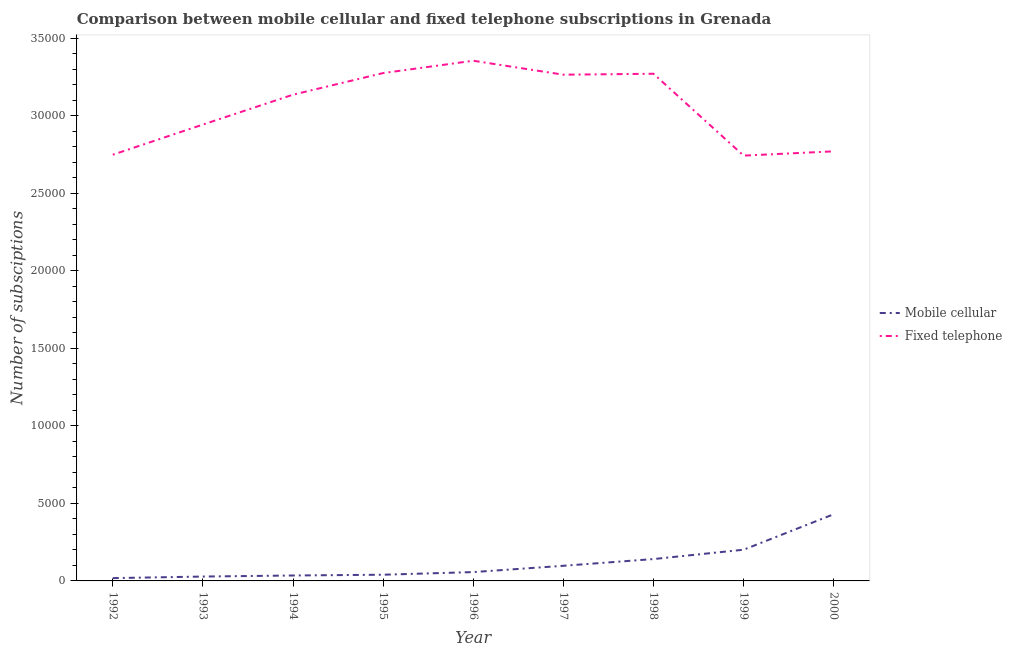Does the line corresponding to number of mobile cellular subscriptions intersect with the line corresponding to number of fixed telephone subscriptions?
Keep it short and to the point. No. Across all years, what is the maximum number of mobile cellular subscriptions?
Your response must be concise. 4300. Across all years, what is the minimum number of mobile cellular subscriptions?
Make the answer very short. 181. What is the total number of mobile cellular subscriptions in the graph?
Offer a very short reply. 1.05e+04. What is the difference between the number of fixed telephone subscriptions in 1997 and that in 1999?
Your answer should be very brief. 5218. What is the difference between the number of fixed telephone subscriptions in 1992 and the number of mobile cellular subscriptions in 1995?
Keep it short and to the point. 2.71e+04. What is the average number of fixed telephone subscriptions per year?
Ensure brevity in your answer.  3.06e+04. In the year 1996, what is the difference between the number of fixed telephone subscriptions and number of mobile cellular subscriptions?
Give a very brief answer. 3.30e+04. What is the ratio of the number of mobile cellular subscriptions in 1993 to that in 1996?
Offer a terse response. 0.49. Is the number of mobile cellular subscriptions in 1995 less than that in 2000?
Your answer should be compact. Yes. What is the difference between the highest and the second highest number of mobile cellular subscriptions?
Keep it short and to the point. 2288. What is the difference between the highest and the lowest number of mobile cellular subscriptions?
Provide a short and direct response. 4119. Does the number of mobile cellular subscriptions monotonically increase over the years?
Your answer should be very brief. Yes. Is the number of mobile cellular subscriptions strictly less than the number of fixed telephone subscriptions over the years?
Keep it short and to the point. Yes. Does the graph contain grids?
Offer a very short reply. No. What is the title of the graph?
Give a very brief answer. Comparison between mobile cellular and fixed telephone subscriptions in Grenada. Does "Formally registered" appear as one of the legend labels in the graph?
Keep it short and to the point. No. What is the label or title of the X-axis?
Keep it short and to the point. Year. What is the label or title of the Y-axis?
Your response must be concise. Number of subsciptions. What is the Number of subsciptions of Mobile cellular in 1992?
Offer a terse response. 181. What is the Number of subsciptions in Fixed telephone in 1992?
Offer a very short reply. 2.75e+04. What is the Number of subsciptions in Mobile cellular in 1993?
Offer a terse response. 282. What is the Number of subsciptions in Fixed telephone in 1993?
Make the answer very short. 2.94e+04. What is the Number of subsciptions of Mobile cellular in 1994?
Give a very brief answer. 350. What is the Number of subsciptions in Fixed telephone in 1994?
Make the answer very short. 3.14e+04. What is the Number of subsciptions in Fixed telephone in 1995?
Provide a succinct answer. 3.28e+04. What is the Number of subsciptions of Mobile cellular in 1996?
Provide a short and direct response. 570. What is the Number of subsciptions of Fixed telephone in 1996?
Your response must be concise. 3.35e+04. What is the Number of subsciptions of Mobile cellular in 1997?
Your answer should be compact. 976. What is the Number of subsciptions in Fixed telephone in 1997?
Ensure brevity in your answer.  3.26e+04. What is the Number of subsciptions in Mobile cellular in 1998?
Give a very brief answer. 1410. What is the Number of subsciptions of Fixed telephone in 1998?
Ensure brevity in your answer.  3.27e+04. What is the Number of subsciptions in Mobile cellular in 1999?
Offer a very short reply. 2012. What is the Number of subsciptions of Fixed telephone in 1999?
Make the answer very short. 2.74e+04. What is the Number of subsciptions of Mobile cellular in 2000?
Provide a succinct answer. 4300. What is the Number of subsciptions of Fixed telephone in 2000?
Keep it short and to the point. 2.77e+04. Across all years, what is the maximum Number of subsciptions of Mobile cellular?
Offer a very short reply. 4300. Across all years, what is the maximum Number of subsciptions in Fixed telephone?
Your answer should be very brief. 3.35e+04. Across all years, what is the minimum Number of subsciptions in Mobile cellular?
Make the answer very short. 181. Across all years, what is the minimum Number of subsciptions of Fixed telephone?
Make the answer very short. 2.74e+04. What is the total Number of subsciptions in Mobile cellular in the graph?
Provide a short and direct response. 1.05e+04. What is the total Number of subsciptions in Fixed telephone in the graph?
Provide a short and direct response. 2.75e+05. What is the difference between the Number of subsciptions of Mobile cellular in 1992 and that in 1993?
Ensure brevity in your answer.  -101. What is the difference between the Number of subsciptions of Fixed telephone in 1992 and that in 1993?
Offer a terse response. -1945. What is the difference between the Number of subsciptions in Mobile cellular in 1992 and that in 1994?
Offer a terse response. -169. What is the difference between the Number of subsciptions in Fixed telephone in 1992 and that in 1994?
Ensure brevity in your answer.  -3871. What is the difference between the Number of subsciptions of Mobile cellular in 1992 and that in 1995?
Your answer should be compact. -219. What is the difference between the Number of subsciptions in Fixed telephone in 1992 and that in 1995?
Your response must be concise. -5266. What is the difference between the Number of subsciptions in Mobile cellular in 1992 and that in 1996?
Your answer should be very brief. -389. What is the difference between the Number of subsciptions of Fixed telephone in 1992 and that in 1996?
Your response must be concise. -6060. What is the difference between the Number of subsciptions in Mobile cellular in 1992 and that in 1997?
Your answer should be very brief. -795. What is the difference between the Number of subsciptions in Fixed telephone in 1992 and that in 1997?
Offer a terse response. -5160. What is the difference between the Number of subsciptions of Mobile cellular in 1992 and that in 1998?
Keep it short and to the point. -1229. What is the difference between the Number of subsciptions in Fixed telephone in 1992 and that in 1998?
Your answer should be compact. -5221. What is the difference between the Number of subsciptions in Mobile cellular in 1992 and that in 1999?
Offer a terse response. -1831. What is the difference between the Number of subsciptions in Fixed telephone in 1992 and that in 1999?
Provide a succinct answer. 58. What is the difference between the Number of subsciptions in Mobile cellular in 1992 and that in 2000?
Your answer should be compact. -4119. What is the difference between the Number of subsciptions of Fixed telephone in 1992 and that in 2000?
Keep it short and to the point. -218. What is the difference between the Number of subsciptions in Mobile cellular in 1993 and that in 1994?
Keep it short and to the point. -68. What is the difference between the Number of subsciptions of Fixed telephone in 1993 and that in 1994?
Your response must be concise. -1926. What is the difference between the Number of subsciptions of Mobile cellular in 1993 and that in 1995?
Offer a very short reply. -118. What is the difference between the Number of subsciptions of Fixed telephone in 1993 and that in 1995?
Make the answer very short. -3321. What is the difference between the Number of subsciptions in Mobile cellular in 1993 and that in 1996?
Provide a succinct answer. -288. What is the difference between the Number of subsciptions of Fixed telephone in 1993 and that in 1996?
Your answer should be compact. -4115. What is the difference between the Number of subsciptions of Mobile cellular in 1993 and that in 1997?
Keep it short and to the point. -694. What is the difference between the Number of subsciptions in Fixed telephone in 1993 and that in 1997?
Your response must be concise. -3215. What is the difference between the Number of subsciptions in Mobile cellular in 1993 and that in 1998?
Your response must be concise. -1128. What is the difference between the Number of subsciptions in Fixed telephone in 1993 and that in 1998?
Offer a terse response. -3276. What is the difference between the Number of subsciptions of Mobile cellular in 1993 and that in 1999?
Provide a short and direct response. -1730. What is the difference between the Number of subsciptions of Fixed telephone in 1993 and that in 1999?
Offer a terse response. 2003. What is the difference between the Number of subsciptions of Mobile cellular in 1993 and that in 2000?
Give a very brief answer. -4018. What is the difference between the Number of subsciptions of Fixed telephone in 1993 and that in 2000?
Keep it short and to the point. 1727. What is the difference between the Number of subsciptions in Mobile cellular in 1994 and that in 1995?
Your answer should be very brief. -50. What is the difference between the Number of subsciptions in Fixed telephone in 1994 and that in 1995?
Provide a succinct answer. -1395. What is the difference between the Number of subsciptions of Mobile cellular in 1994 and that in 1996?
Your answer should be very brief. -220. What is the difference between the Number of subsciptions of Fixed telephone in 1994 and that in 1996?
Provide a short and direct response. -2189. What is the difference between the Number of subsciptions in Mobile cellular in 1994 and that in 1997?
Ensure brevity in your answer.  -626. What is the difference between the Number of subsciptions of Fixed telephone in 1994 and that in 1997?
Ensure brevity in your answer.  -1289. What is the difference between the Number of subsciptions in Mobile cellular in 1994 and that in 1998?
Offer a very short reply. -1060. What is the difference between the Number of subsciptions of Fixed telephone in 1994 and that in 1998?
Offer a very short reply. -1350. What is the difference between the Number of subsciptions in Mobile cellular in 1994 and that in 1999?
Your response must be concise. -1662. What is the difference between the Number of subsciptions in Fixed telephone in 1994 and that in 1999?
Offer a very short reply. 3929. What is the difference between the Number of subsciptions in Mobile cellular in 1994 and that in 2000?
Give a very brief answer. -3950. What is the difference between the Number of subsciptions of Fixed telephone in 1994 and that in 2000?
Your answer should be very brief. 3653. What is the difference between the Number of subsciptions of Mobile cellular in 1995 and that in 1996?
Offer a very short reply. -170. What is the difference between the Number of subsciptions of Fixed telephone in 1995 and that in 1996?
Offer a very short reply. -794. What is the difference between the Number of subsciptions of Mobile cellular in 1995 and that in 1997?
Provide a succinct answer. -576. What is the difference between the Number of subsciptions of Fixed telephone in 1995 and that in 1997?
Ensure brevity in your answer.  106. What is the difference between the Number of subsciptions in Mobile cellular in 1995 and that in 1998?
Provide a succinct answer. -1010. What is the difference between the Number of subsciptions in Mobile cellular in 1995 and that in 1999?
Provide a short and direct response. -1612. What is the difference between the Number of subsciptions of Fixed telephone in 1995 and that in 1999?
Ensure brevity in your answer.  5324. What is the difference between the Number of subsciptions in Mobile cellular in 1995 and that in 2000?
Provide a succinct answer. -3900. What is the difference between the Number of subsciptions of Fixed telephone in 1995 and that in 2000?
Make the answer very short. 5048. What is the difference between the Number of subsciptions of Mobile cellular in 1996 and that in 1997?
Offer a very short reply. -406. What is the difference between the Number of subsciptions of Fixed telephone in 1996 and that in 1997?
Provide a short and direct response. 900. What is the difference between the Number of subsciptions of Mobile cellular in 1996 and that in 1998?
Ensure brevity in your answer.  -840. What is the difference between the Number of subsciptions in Fixed telephone in 1996 and that in 1998?
Your response must be concise. 839. What is the difference between the Number of subsciptions in Mobile cellular in 1996 and that in 1999?
Offer a very short reply. -1442. What is the difference between the Number of subsciptions of Fixed telephone in 1996 and that in 1999?
Your response must be concise. 6118. What is the difference between the Number of subsciptions of Mobile cellular in 1996 and that in 2000?
Provide a short and direct response. -3730. What is the difference between the Number of subsciptions of Fixed telephone in 1996 and that in 2000?
Your answer should be compact. 5842. What is the difference between the Number of subsciptions of Mobile cellular in 1997 and that in 1998?
Ensure brevity in your answer.  -434. What is the difference between the Number of subsciptions in Fixed telephone in 1997 and that in 1998?
Make the answer very short. -61. What is the difference between the Number of subsciptions of Mobile cellular in 1997 and that in 1999?
Your answer should be very brief. -1036. What is the difference between the Number of subsciptions in Fixed telephone in 1997 and that in 1999?
Your answer should be compact. 5218. What is the difference between the Number of subsciptions in Mobile cellular in 1997 and that in 2000?
Offer a very short reply. -3324. What is the difference between the Number of subsciptions in Fixed telephone in 1997 and that in 2000?
Your response must be concise. 4942. What is the difference between the Number of subsciptions in Mobile cellular in 1998 and that in 1999?
Offer a very short reply. -602. What is the difference between the Number of subsciptions in Fixed telephone in 1998 and that in 1999?
Your answer should be compact. 5279. What is the difference between the Number of subsciptions of Mobile cellular in 1998 and that in 2000?
Your answer should be very brief. -2890. What is the difference between the Number of subsciptions of Fixed telephone in 1998 and that in 2000?
Provide a succinct answer. 5003. What is the difference between the Number of subsciptions of Mobile cellular in 1999 and that in 2000?
Your answer should be compact. -2288. What is the difference between the Number of subsciptions of Fixed telephone in 1999 and that in 2000?
Provide a short and direct response. -276. What is the difference between the Number of subsciptions in Mobile cellular in 1992 and the Number of subsciptions in Fixed telephone in 1993?
Offer a terse response. -2.92e+04. What is the difference between the Number of subsciptions in Mobile cellular in 1992 and the Number of subsciptions in Fixed telephone in 1994?
Give a very brief answer. -3.12e+04. What is the difference between the Number of subsciptions of Mobile cellular in 1992 and the Number of subsciptions of Fixed telephone in 1995?
Provide a short and direct response. -3.26e+04. What is the difference between the Number of subsciptions in Mobile cellular in 1992 and the Number of subsciptions in Fixed telephone in 1996?
Offer a very short reply. -3.34e+04. What is the difference between the Number of subsciptions in Mobile cellular in 1992 and the Number of subsciptions in Fixed telephone in 1997?
Offer a very short reply. -3.25e+04. What is the difference between the Number of subsciptions in Mobile cellular in 1992 and the Number of subsciptions in Fixed telephone in 1998?
Offer a very short reply. -3.25e+04. What is the difference between the Number of subsciptions of Mobile cellular in 1992 and the Number of subsciptions of Fixed telephone in 1999?
Ensure brevity in your answer.  -2.72e+04. What is the difference between the Number of subsciptions of Mobile cellular in 1992 and the Number of subsciptions of Fixed telephone in 2000?
Offer a terse response. -2.75e+04. What is the difference between the Number of subsciptions in Mobile cellular in 1993 and the Number of subsciptions in Fixed telephone in 1994?
Your answer should be very brief. -3.11e+04. What is the difference between the Number of subsciptions in Mobile cellular in 1993 and the Number of subsciptions in Fixed telephone in 1995?
Offer a very short reply. -3.25e+04. What is the difference between the Number of subsciptions of Mobile cellular in 1993 and the Number of subsciptions of Fixed telephone in 1996?
Offer a terse response. -3.33e+04. What is the difference between the Number of subsciptions of Mobile cellular in 1993 and the Number of subsciptions of Fixed telephone in 1997?
Offer a terse response. -3.24e+04. What is the difference between the Number of subsciptions of Mobile cellular in 1993 and the Number of subsciptions of Fixed telephone in 1998?
Provide a short and direct response. -3.24e+04. What is the difference between the Number of subsciptions in Mobile cellular in 1993 and the Number of subsciptions in Fixed telephone in 1999?
Ensure brevity in your answer.  -2.71e+04. What is the difference between the Number of subsciptions in Mobile cellular in 1993 and the Number of subsciptions in Fixed telephone in 2000?
Keep it short and to the point. -2.74e+04. What is the difference between the Number of subsciptions in Mobile cellular in 1994 and the Number of subsciptions in Fixed telephone in 1995?
Offer a terse response. -3.24e+04. What is the difference between the Number of subsciptions of Mobile cellular in 1994 and the Number of subsciptions of Fixed telephone in 1996?
Give a very brief answer. -3.32e+04. What is the difference between the Number of subsciptions of Mobile cellular in 1994 and the Number of subsciptions of Fixed telephone in 1997?
Provide a short and direct response. -3.23e+04. What is the difference between the Number of subsciptions in Mobile cellular in 1994 and the Number of subsciptions in Fixed telephone in 1998?
Your answer should be compact. -3.24e+04. What is the difference between the Number of subsciptions in Mobile cellular in 1994 and the Number of subsciptions in Fixed telephone in 1999?
Give a very brief answer. -2.71e+04. What is the difference between the Number of subsciptions in Mobile cellular in 1994 and the Number of subsciptions in Fixed telephone in 2000?
Your answer should be very brief. -2.74e+04. What is the difference between the Number of subsciptions of Mobile cellular in 1995 and the Number of subsciptions of Fixed telephone in 1996?
Your answer should be compact. -3.31e+04. What is the difference between the Number of subsciptions of Mobile cellular in 1995 and the Number of subsciptions of Fixed telephone in 1997?
Provide a short and direct response. -3.22e+04. What is the difference between the Number of subsciptions of Mobile cellular in 1995 and the Number of subsciptions of Fixed telephone in 1998?
Your answer should be very brief. -3.23e+04. What is the difference between the Number of subsciptions in Mobile cellular in 1995 and the Number of subsciptions in Fixed telephone in 1999?
Your response must be concise. -2.70e+04. What is the difference between the Number of subsciptions in Mobile cellular in 1995 and the Number of subsciptions in Fixed telephone in 2000?
Provide a succinct answer. -2.73e+04. What is the difference between the Number of subsciptions in Mobile cellular in 1996 and the Number of subsciptions in Fixed telephone in 1997?
Provide a short and direct response. -3.21e+04. What is the difference between the Number of subsciptions of Mobile cellular in 1996 and the Number of subsciptions of Fixed telephone in 1998?
Ensure brevity in your answer.  -3.21e+04. What is the difference between the Number of subsciptions in Mobile cellular in 1996 and the Number of subsciptions in Fixed telephone in 1999?
Offer a terse response. -2.69e+04. What is the difference between the Number of subsciptions in Mobile cellular in 1996 and the Number of subsciptions in Fixed telephone in 2000?
Provide a short and direct response. -2.71e+04. What is the difference between the Number of subsciptions in Mobile cellular in 1997 and the Number of subsciptions in Fixed telephone in 1998?
Ensure brevity in your answer.  -3.17e+04. What is the difference between the Number of subsciptions in Mobile cellular in 1997 and the Number of subsciptions in Fixed telephone in 1999?
Provide a succinct answer. -2.64e+04. What is the difference between the Number of subsciptions in Mobile cellular in 1997 and the Number of subsciptions in Fixed telephone in 2000?
Make the answer very short. -2.67e+04. What is the difference between the Number of subsciptions of Mobile cellular in 1998 and the Number of subsciptions of Fixed telephone in 1999?
Offer a very short reply. -2.60e+04. What is the difference between the Number of subsciptions of Mobile cellular in 1998 and the Number of subsciptions of Fixed telephone in 2000?
Provide a short and direct response. -2.63e+04. What is the difference between the Number of subsciptions of Mobile cellular in 1999 and the Number of subsciptions of Fixed telephone in 2000?
Provide a short and direct response. -2.57e+04. What is the average Number of subsciptions of Mobile cellular per year?
Offer a very short reply. 1164.56. What is the average Number of subsciptions of Fixed telephone per year?
Your response must be concise. 3.06e+04. In the year 1992, what is the difference between the Number of subsciptions in Mobile cellular and Number of subsciptions in Fixed telephone?
Offer a terse response. -2.73e+04. In the year 1993, what is the difference between the Number of subsciptions of Mobile cellular and Number of subsciptions of Fixed telephone?
Provide a short and direct response. -2.91e+04. In the year 1994, what is the difference between the Number of subsciptions of Mobile cellular and Number of subsciptions of Fixed telephone?
Your answer should be very brief. -3.10e+04. In the year 1995, what is the difference between the Number of subsciptions of Mobile cellular and Number of subsciptions of Fixed telephone?
Offer a very short reply. -3.24e+04. In the year 1996, what is the difference between the Number of subsciptions of Mobile cellular and Number of subsciptions of Fixed telephone?
Give a very brief answer. -3.30e+04. In the year 1997, what is the difference between the Number of subsciptions in Mobile cellular and Number of subsciptions in Fixed telephone?
Give a very brief answer. -3.17e+04. In the year 1998, what is the difference between the Number of subsciptions in Mobile cellular and Number of subsciptions in Fixed telephone?
Give a very brief answer. -3.13e+04. In the year 1999, what is the difference between the Number of subsciptions of Mobile cellular and Number of subsciptions of Fixed telephone?
Make the answer very short. -2.54e+04. In the year 2000, what is the difference between the Number of subsciptions in Mobile cellular and Number of subsciptions in Fixed telephone?
Keep it short and to the point. -2.34e+04. What is the ratio of the Number of subsciptions in Mobile cellular in 1992 to that in 1993?
Give a very brief answer. 0.64. What is the ratio of the Number of subsciptions of Fixed telephone in 1992 to that in 1993?
Your answer should be very brief. 0.93. What is the ratio of the Number of subsciptions in Mobile cellular in 1992 to that in 1994?
Keep it short and to the point. 0.52. What is the ratio of the Number of subsciptions of Fixed telephone in 1992 to that in 1994?
Your response must be concise. 0.88. What is the ratio of the Number of subsciptions of Mobile cellular in 1992 to that in 1995?
Your answer should be compact. 0.45. What is the ratio of the Number of subsciptions in Fixed telephone in 1992 to that in 1995?
Keep it short and to the point. 0.84. What is the ratio of the Number of subsciptions of Mobile cellular in 1992 to that in 1996?
Your answer should be compact. 0.32. What is the ratio of the Number of subsciptions in Fixed telephone in 1992 to that in 1996?
Ensure brevity in your answer.  0.82. What is the ratio of the Number of subsciptions of Mobile cellular in 1992 to that in 1997?
Offer a very short reply. 0.19. What is the ratio of the Number of subsciptions in Fixed telephone in 1992 to that in 1997?
Offer a very short reply. 0.84. What is the ratio of the Number of subsciptions in Mobile cellular in 1992 to that in 1998?
Ensure brevity in your answer.  0.13. What is the ratio of the Number of subsciptions of Fixed telephone in 1992 to that in 1998?
Your answer should be very brief. 0.84. What is the ratio of the Number of subsciptions of Mobile cellular in 1992 to that in 1999?
Your answer should be compact. 0.09. What is the ratio of the Number of subsciptions in Fixed telephone in 1992 to that in 1999?
Your answer should be very brief. 1. What is the ratio of the Number of subsciptions of Mobile cellular in 1992 to that in 2000?
Your answer should be very brief. 0.04. What is the ratio of the Number of subsciptions of Fixed telephone in 1992 to that in 2000?
Ensure brevity in your answer.  0.99. What is the ratio of the Number of subsciptions in Mobile cellular in 1993 to that in 1994?
Keep it short and to the point. 0.81. What is the ratio of the Number of subsciptions in Fixed telephone in 1993 to that in 1994?
Offer a very short reply. 0.94. What is the ratio of the Number of subsciptions in Mobile cellular in 1993 to that in 1995?
Give a very brief answer. 0.7. What is the ratio of the Number of subsciptions of Fixed telephone in 1993 to that in 1995?
Your answer should be very brief. 0.9. What is the ratio of the Number of subsciptions in Mobile cellular in 1993 to that in 1996?
Your answer should be compact. 0.49. What is the ratio of the Number of subsciptions of Fixed telephone in 1993 to that in 1996?
Provide a succinct answer. 0.88. What is the ratio of the Number of subsciptions in Mobile cellular in 1993 to that in 1997?
Provide a succinct answer. 0.29. What is the ratio of the Number of subsciptions of Fixed telephone in 1993 to that in 1997?
Offer a terse response. 0.9. What is the ratio of the Number of subsciptions in Mobile cellular in 1993 to that in 1998?
Offer a very short reply. 0.2. What is the ratio of the Number of subsciptions in Fixed telephone in 1993 to that in 1998?
Provide a short and direct response. 0.9. What is the ratio of the Number of subsciptions of Mobile cellular in 1993 to that in 1999?
Give a very brief answer. 0.14. What is the ratio of the Number of subsciptions of Fixed telephone in 1993 to that in 1999?
Provide a succinct answer. 1.07. What is the ratio of the Number of subsciptions of Mobile cellular in 1993 to that in 2000?
Ensure brevity in your answer.  0.07. What is the ratio of the Number of subsciptions of Fixed telephone in 1993 to that in 2000?
Provide a succinct answer. 1.06. What is the ratio of the Number of subsciptions of Mobile cellular in 1994 to that in 1995?
Your answer should be compact. 0.88. What is the ratio of the Number of subsciptions in Fixed telephone in 1994 to that in 1995?
Give a very brief answer. 0.96. What is the ratio of the Number of subsciptions in Mobile cellular in 1994 to that in 1996?
Ensure brevity in your answer.  0.61. What is the ratio of the Number of subsciptions in Fixed telephone in 1994 to that in 1996?
Your answer should be very brief. 0.93. What is the ratio of the Number of subsciptions of Mobile cellular in 1994 to that in 1997?
Your response must be concise. 0.36. What is the ratio of the Number of subsciptions in Fixed telephone in 1994 to that in 1997?
Make the answer very short. 0.96. What is the ratio of the Number of subsciptions of Mobile cellular in 1994 to that in 1998?
Offer a terse response. 0.25. What is the ratio of the Number of subsciptions in Fixed telephone in 1994 to that in 1998?
Offer a terse response. 0.96. What is the ratio of the Number of subsciptions in Mobile cellular in 1994 to that in 1999?
Ensure brevity in your answer.  0.17. What is the ratio of the Number of subsciptions of Fixed telephone in 1994 to that in 1999?
Provide a short and direct response. 1.14. What is the ratio of the Number of subsciptions in Mobile cellular in 1994 to that in 2000?
Your response must be concise. 0.08. What is the ratio of the Number of subsciptions in Fixed telephone in 1994 to that in 2000?
Offer a very short reply. 1.13. What is the ratio of the Number of subsciptions of Mobile cellular in 1995 to that in 1996?
Your response must be concise. 0.7. What is the ratio of the Number of subsciptions in Fixed telephone in 1995 to that in 1996?
Your answer should be very brief. 0.98. What is the ratio of the Number of subsciptions of Mobile cellular in 1995 to that in 1997?
Make the answer very short. 0.41. What is the ratio of the Number of subsciptions of Fixed telephone in 1995 to that in 1997?
Your response must be concise. 1. What is the ratio of the Number of subsciptions of Mobile cellular in 1995 to that in 1998?
Ensure brevity in your answer.  0.28. What is the ratio of the Number of subsciptions in Fixed telephone in 1995 to that in 1998?
Provide a short and direct response. 1. What is the ratio of the Number of subsciptions in Mobile cellular in 1995 to that in 1999?
Your response must be concise. 0.2. What is the ratio of the Number of subsciptions of Fixed telephone in 1995 to that in 1999?
Your answer should be very brief. 1.19. What is the ratio of the Number of subsciptions of Mobile cellular in 1995 to that in 2000?
Make the answer very short. 0.09. What is the ratio of the Number of subsciptions of Fixed telephone in 1995 to that in 2000?
Your answer should be very brief. 1.18. What is the ratio of the Number of subsciptions of Mobile cellular in 1996 to that in 1997?
Provide a succinct answer. 0.58. What is the ratio of the Number of subsciptions of Fixed telephone in 1996 to that in 1997?
Ensure brevity in your answer.  1.03. What is the ratio of the Number of subsciptions of Mobile cellular in 1996 to that in 1998?
Your answer should be very brief. 0.4. What is the ratio of the Number of subsciptions in Fixed telephone in 1996 to that in 1998?
Offer a very short reply. 1.03. What is the ratio of the Number of subsciptions in Mobile cellular in 1996 to that in 1999?
Provide a short and direct response. 0.28. What is the ratio of the Number of subsciptions in Fixed telephone in 1996 to that in 1999?
Offer a terse response. 1.22. What is the ratio of the Number of subsciptions in Mobile cellular in 1996 to that in 2000?
Your response must be concise. 0.13. What is the ratio of the Number of subsciptions of Fixed telephone in 1996 to that in 2000?
Make the answer very short. 1.21. What is the ratio of the Number of subsciptions in Mobile cellular in 1997 to that in 1998?
Your answer should be compact. 0.69. What is the ratio of the Number of subsciptions in Fixed telephone in 1997 to that in 1998?
Ensure brevity in your answer.  1. What is the ratio of the Number of subsciptions of Mobile cellular in 1997 to that in 1999?
Make the answer very short. 0.49. What is the ratio of the Number of subsciptions of Fixed telephone in 1997 to that in 1999?
Keep it short and to the point. 1.19. What is the ratio of the Number of subsciptions of Mobile cellular in 1997 to that in 2000?
Your answer should be very brief. 0.23. What is the ratio of the Number of subsciptions of Fixed telephone in 1997 to that in 2000?
Your answer should be compact. 1.18. What is the ratio of the Number of subsciptions of Mobile cellular in 1998 to that in 1999?
Offer a terse response. 0.7. What is the ratio of the Number of subsciptions of Fixed telephone in 1998 to that in 1999?
Provide a succinct answer. 1.19. What is the ratio of the Number of subsciptions in Mobile cellular in 1998 to that in 2000?
Ensure brevity in your answer.  0.33. What is the ratio of the Number of subsciptions in Fixed telephone in 1998 to that in 2000?
Offer a very short reply. 1.18. What is the ratio of the Number of subsciptions in Mobile cellular in 1999 to that in 2000?
Offer a very short reply. 0.47. What is the difference between the highest and the second highest Number of subsciptions in Mobile cellular?
Provide a short and direct response. 2288. What is the difference between the highest and the second highest Number of subsciptions in Fixed telephone?
Your response must be concise. 794. What is the difference between the highest and the lowest Number of subsciptions in Mobile cellular?
Offer a terse response. 4119. What is the difference between the highest and the lowest Number of subsciptions in Fixed telephone?
Offer a terse response. 6118. 